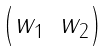<formula> <loc_0><loc_0><loc_500><loc_500>\begin{pmatrix} w _ { 1 } & w _ { 2 } \end{pmatrix}</formula> 